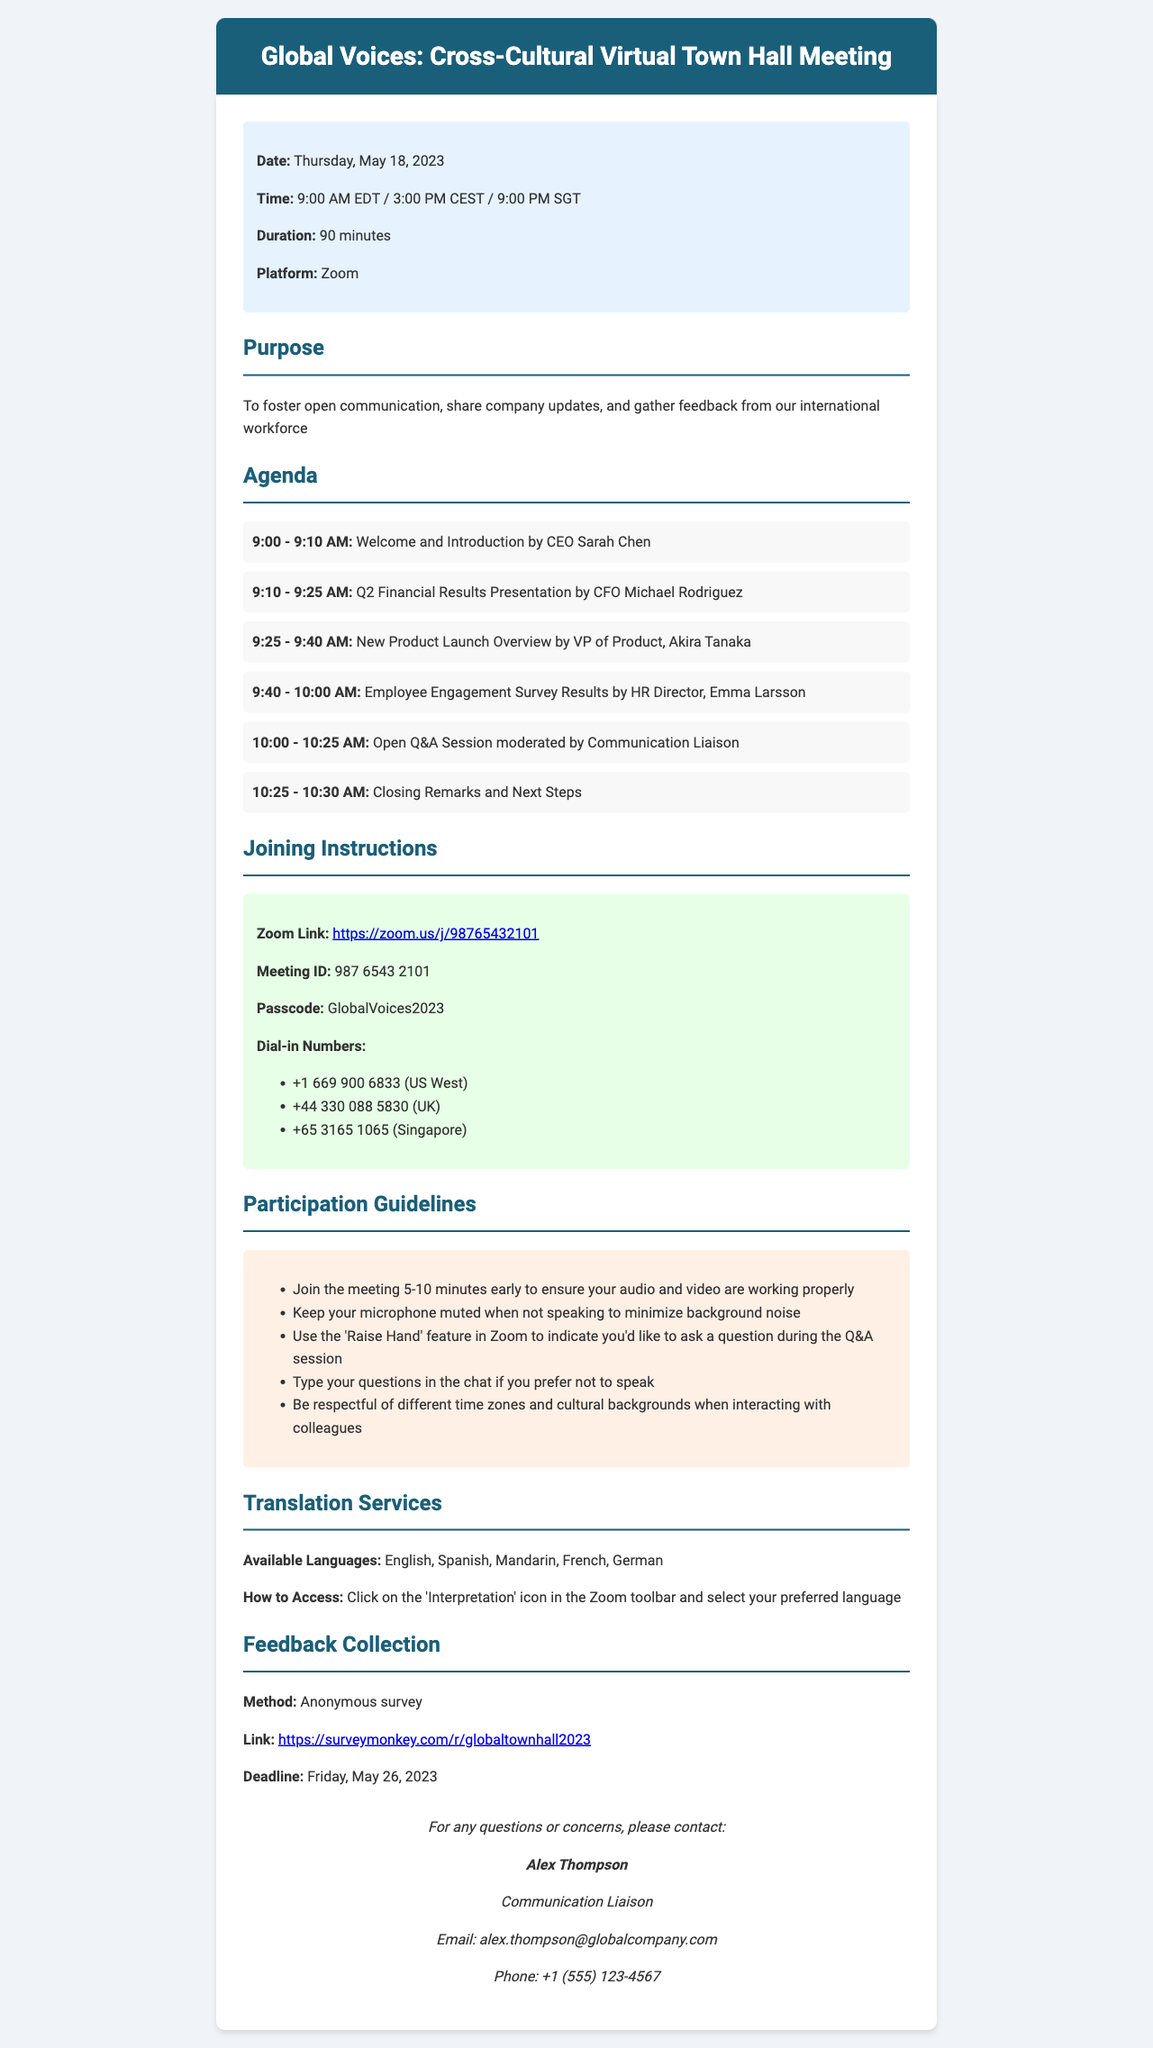What is the title of the meeting? The title of the meeting is stated in the event details section.
Answer: Global Voices: Cross-Cultural Virtual Town Hall Meeting When will the town hall meeting take place? The date of the meeting is listed under the event details.
Answer: Thursday, May 18, 2023 How long is the meeting scheduled to last? The duration of the meeting can be found in the event details section.
Answer: 90 minutes Who will present the Q2 Financial Results? The CFO presenting the financial results is named in the agenda section.
Answer: Michael Rodriguez What is the method for feedback collection? The method for collecting feedback is specified in the feedback collection section.
Answer: Anonymous survey What is the time of the open Q&A session? The timing of the Q&A session is found in the agenda section and spans a specific duration.
Answer: 10:00 - 10:25 AM Which platform will be used for the meeting? The platform through which the meeting will be conducted is mentioned in the event details.
Answer: Zoom What languages are available for translation services? The available languages for translation are listed under the translation services section.
Answer: English, Spanish, Mandarin, French, German Who should be contacted for questions? The contact information for inquiries includes the name and title of a specific person.
Answer: Alex Thompson 